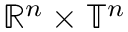<formula> <loc_0><loc_0><loc_500><loc_500>\mathbb { R } ^ { n } \times \mathbb { T } ^ { n }</formula> 